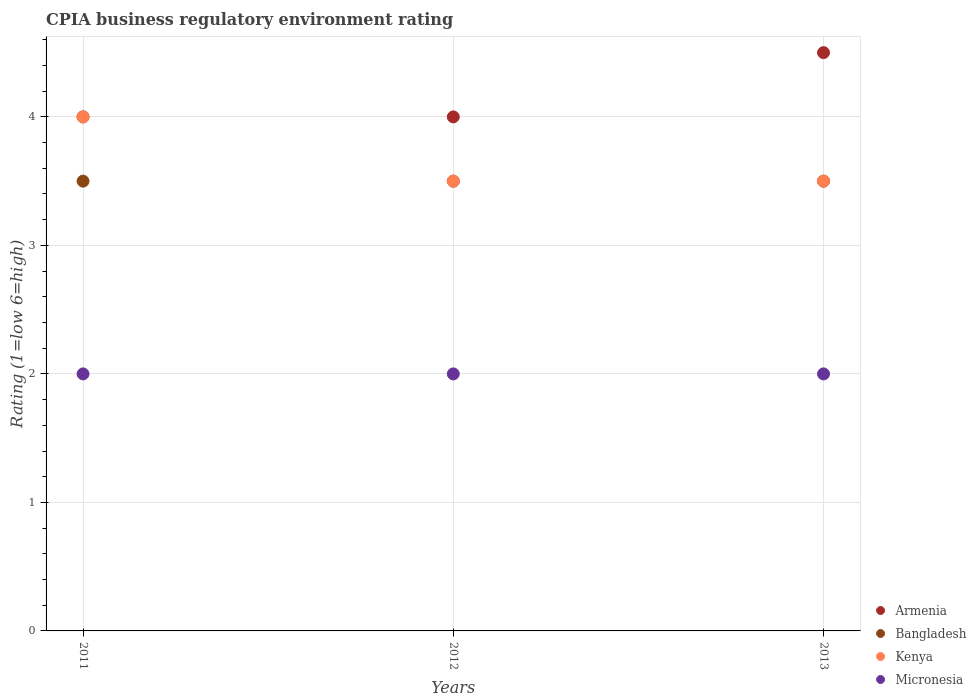How many different coloured dotlines are there?
Ensure brevity in your answer.  4. Is the number of dotlines equal to the number of legend labels?
Provide a succinct answer. Yes. What is the CPIA rating in Bangladesh in 2011?
Provide a succinct answer. 3.5. Across all years, what is the maximum CPIA rating in Micronesia?
Offer a very short reply. 2. In which year was the CPIA rating in Bangladesh maximum?
Keep it short and to the point. 2011. In which year was the CPIA rating in Armenia minimum?
Offer a very short reply. 2011. What is the difference between the CPIA rating in Kenya in 2011 and the CPIA rating in Micronesia in 2013?
Offer a terse response. 2. What is the average CPIA rating in Armenia per year?
Make the answer very short. 4.17. In the year 2012, what is the difference between the CPIA rating in Armenia and CPIA rating in Kenya?
Ensure brevity in your answer.  0.5. In how many years, is the CPIA rating in Kenya greater than 0.2?
Provide a short and direct response. 3. Is the CPIA rating in Kenya in 2012 less than that in 2013?
Make the answer very short. No. Is the difference between the CPIA rating in Armenia in 2011 and 2012 greater than the difference between the CPIA rating in Kenya in 2011 and 2012?
Ensure brevity in your answer.  No. What is the difference between the highest and the second highest CPIA rating in Armenia?
Make the answer very short. 0.5. What is the difference between the highest and the lowest CPIA rating in Armenia?
Your answer should be compact. 0.5. Is it the case that in every year, the sum of the CPIA rating in Micronesia and CPIA rating in Armenia  is greater than the CPIA rating in Kenya?
Provide a short and direct response. Yes. How many years are there in the graph?
Your answer should be very brief. 3. Are the values on the major ticks of Y-axis written in scientific E-notation?
Your response must be concise. No. Does the graph contain any zero values?
Your answer should be compact. No. How many legend labels are there?
Your answer should be compact. 4. What is the title of the graph?
Make the answer very short. CPIA business regulatory environment rating. Does "Colombia" appear as one of the legend labels in the graph?
Your answer should be very brief. No. What is the label or title of the X-axis?
Your answer should be very brief. Years. What is the label or title of the Y-axis?
Your response must be concise. Rating (1=low 6=high). What is the Rating (1=low 6=high) of Armenia in 2011?
Make the answer very short. 4. What is the Rating (1=low 6=high) of Bangladesh in 2011?
Your answer should be very brief. 3.5. What is the Rating (1=low 6=high) in Kenya in 2011?
Your answer should be compact. 4. What is the Rating (1=low 6=high) in Armenia in 2012?
Provide a short and direct response. 4. What is the Rating (1=low 6=high) in Kenya in 2012?
Ensure brevity in your answer.  3.5. What is the Rating (1=low 6=high) of Bangladesh in 2013?
Ensure brevity in your answer.  3.5. What is the Rating (1=low 6=high) in Micronesia in 2013?
Your response must be concise. 2. Across all years, what is the maximum Rating (1=low 6=high) of Armenia?
Offer a terse response. 4.5. Across all years, what is the maximum Rating (1=low 6=high) of Bangladesh?
Your response must be concise. 3.5. Across all years, what is the maximum Rating (1=low 6=high) of Micronesia?
Give a very brief answer. 2. Across all years, what is the minimum Rating (1=low 6=high) of Armenia?
Provide a succinct answer. 4. Across all years, what is the minimum Rating (1=low 6=high) of Bangladesh?
Your response must be concise. 3.5. Across all years, what is the minimum Rating (1=low 6=high) in Micronesia?
Ensure brevity in your answer.  2. What is the difference between the Rating (1=low 6=high) of Micronesia in 2011 and that in 2012?
Ensure brevity in your answer.  0. What is the difference between the Rating (1=low 6=high) in Armenia in 2011 and that in 2013?
Give a very brief answer. -0.5. What is the difference between the Rating (1=low 6=high) of Bangladesh in 2011 and that in 2013?
Ensure brevity in your answer.  0. What is the difference between the Rating (1=low 6=high) in Kenya in 2011 and that in 2013?
Provide a succinct answer. 0.5. What is the difference between the Rating (1=low 6=high) of Micronesia in 2011 and that in 2013?
Make the answer very short. 0. What is the difference between the Rating (1=low 6=high) of Armenia in 2012 and that in 2013?
Your answer should be compact. -0.5. What is the difference between the Rating (1=low 6=high) in Bangladesh in 2012 and that in 2013?
Your response must be concise. 0. What is the difference between the Rating (1=low 6=high) in Kenya in 2012 and that in 2013?
Provide a succinct answer. 0. What is the difference between the Rating (1=low 6=high) of Micronesia in 2012 and that in 2013?
Your answer should be compact. 0. What is the difference between the Rating (1=low 6=high) of Armenia in 2011 and the Rating (1=low 6=high) of Bangladesh in 2012?
Offer a terse response. 0.5. What is the difference between the Rating (1=low 6=high) of Bangladesh in 2011 and the Rating (1=low 6=high) of Micronesia in 2012?
Provide a succinct answer. 1.5. What is the difference between the Rating (1=low 6=high) in Kenya in 2011 and the Rating (1=low 6=high) in Micronesia in 2012?
Offer a terse response. 2. What is the difference between the Rating (1=low 6=high) in Armenia in 2011 and the Rating (1=low 6=high) in Kenya in 2013?
Your answer should be very brief. 0.5. What is the difference between the Rating (1=low 6=high) of Armenia in 2011 and the Rating (1=low 6=high) of Micronesia in 2013?
Make the answer very short. 2. What is the difference between the Rating (1=low 6=high) in Kenya in 2011 and the Rating (1=low 6=high) in Micronesia in 2013?
Provide a succinct answer. 2. What is the difference between the Rating (1=low 6=high) of Armenia in 2012 and the Rating (1=low 6=high) of Bangladesh in 2013?
Give a very brief answer. 0.5. What is the difference between the Rating (1=low 6=high) in Armenia in 2012 and the Rating (1=low 6=high) in Kenya in 2013?
Give a very brief answer. 0.5. What is the difference between the Rating (1=low 6=high) in Bangladesh in 2012 and the Rating (1=low 6=high) in Kenya in 2013?
Provide a succinct answer. 0. What is the average Rating (1=low 6=high) of Armenia per year?
Make the answer very short. 4.17. What is the average Rating (1=low 6=high) of Kenya per year?
Make the answer very short. 3.67. What is the average Rating (1=low 6=high) in Micronesia per year?
Your answer should be very brief. 2. In the year 2011, what is the difference between the Rating (1=low 6=high) of Armenia and Rating (1=low 6=high) of Bangladesh?
Your answer should be compact. 0.5. In the year 2011, what is the difference between the Rating (1=low 6=high) of Bangladesh and Rating (1=low 6=high) of Micronesia?
Make the answer very short. 1.5. In the year 2011, what is the difference between the Rating (1=low 6=high) in Kenya and Rating (1=low 6=high) in Micronesia?
Offer a terse response. 2. In the year 2012, what is the difference between the Rating (1=low 6=high) in Armenia and Rating (1=low 6=high) in Bangladesh?
Make the answer very short. 0.5. In the year 2012, what is the difference between the Rating (1=low 6=high) in Armenia and Rating (1=low 6=high) in Kenya?
Make the answer very short. 0.5. In the year 2012, what is the difference between the Rating (1=low 6=high) in Armenia and Rating (1=low 6=high) in Micronesia?
Keep it short and to the point. 2. In the year 2012, what is the difference between the Rating (1=low 6=high) in Bangladesh and Rating (1=low 6=high) in Micronesia?
Provide a short and direct response. 1.5. In the year 2013, what is the difference between the Rating (1=low 6=high) in Armenia and Rating (1=low 6=high) in Micronesia?
Provide a short and direct response. 2.5. In the year 2013, what is the difference between the Rating (1=low 6=high) in Kenya and Rating (1=low 6=high) in Micronesia?
Your answer should be compact. 1.5. What is the ratio of the Rating (1=low 6=high) in Bangladesh in 2011 to that in 2012?
Keep it short and to the point. 1. What is the ratio of the Rating (1=low 6=high) in Micronesia in 2011 to that in 2012?
Give a very brief answer. 1. What is the ratio of the Rating (1=low 6=high) of Armenia in 2011 to that in 2013?
Your answer should be compact. 0.89. What is the ratio of the Rating (1=low 6=high) in Micronesia in 2011 to that in 2013?
Make the answer very short. 1. What is the ratio of the Rating (1=low 6=high) of Armenia in 2012 to that in 2013?
Provide a short and direct response. 0.89. What is the ratio of the Rating (1=low 6=high) of Bangladesh in 2012 to that in 2013?
Offer a terse response. 1. What is the ratio of the Rating (1=low 6=high) in Kenya in 2012 to that in 2013?
Keep it short and to the point. 1. What is the difference between the highest and the second highest Rating (1=low 6=high) of Bangladesh?
Offer a terse response. 0. What is the difference between the highest and the lowest Rating (1=low 6=high) of Armenia?
Ensure brevity in your answer.  0.5. What is the difference between the highest and the lowest Rating (1=low 6=high) of Bangladesh?
Offer a terse response. 0. 